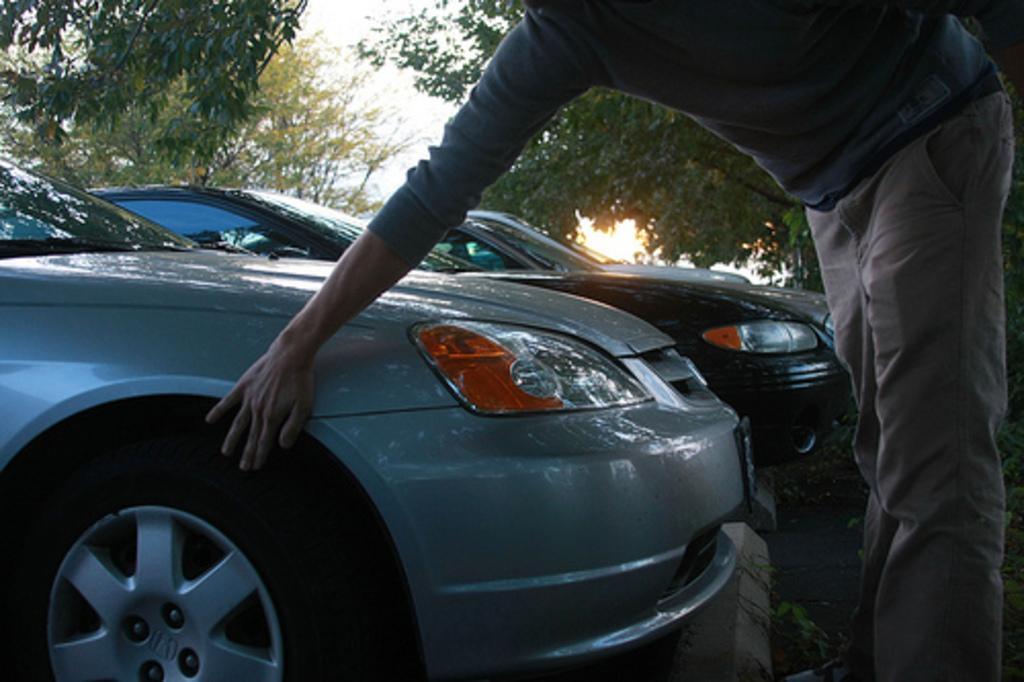Could you give a brief overview of what you see in this image? In this image, we can see a person standing and touching a vehicle. In the background, there are vehicles, trees and the sky. 